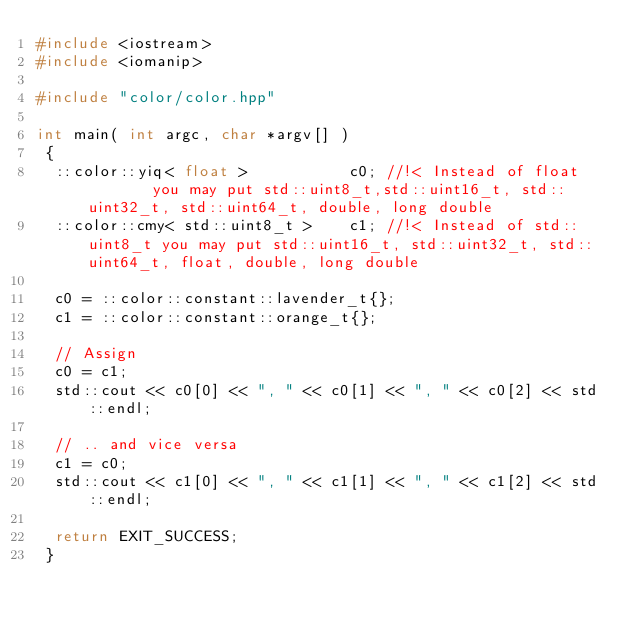Convert code to text. <code><loc_0><loc_0><loc_500><loc_500><_C++_>#include <iostream>
#include <iomanip>

#include "color/color.hpp"

int main( int argc, char *argv[] )
 {
  ::color::yiq< float >           c0; //!< Instead of float        you may put std::uint8_t,std::uint16_t, std::uint32_t, std::uint64_t, double, long double
  ::color::cmy< std::uint8_t >    c1; //!< Instead of std::uint8_t you may put std::uint16_t, std::uint32_t, std::uint64_t, float, double, long double

  c0 = ::color::constant::lavender_t{};
  c1 = ::color::constant::orange_t{};

  // Assign
  c0 = c1;
  std::cout << c0[0] << ", " << c0[1] << ", " << c0[2] << std::endl;

  // .. and vice versa
  c1 = c0;
  std::cout << c1[0] << ", " << c1[1] << ", " << c1[2] << std::endl;

  return EXIT_SUCCESS;
 }
</code> 